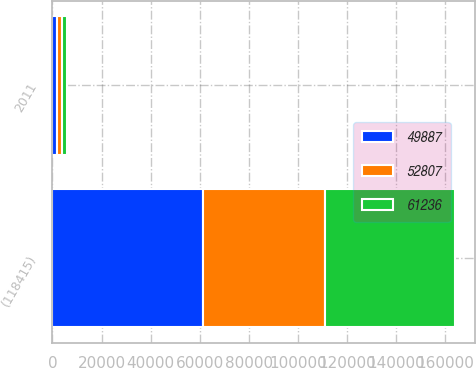Convert chart. <chart><loc_0><loc_0><loc_500><loc_500><stacked_bar_chart><ecel><fcel>2011<fcel>(118415)<nl><fcel>52807<fcel>2010<fcel>49887<nl><fcel>61236<fcel>2009<fcel>52807<nl><fcel>49887<fcel>2008<fcel>61236<nl></chart> 